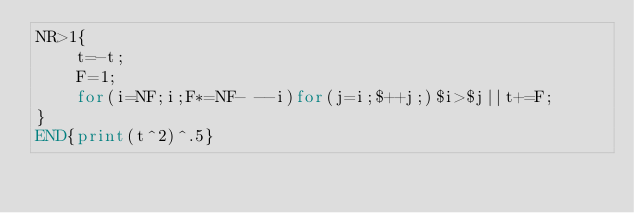Convert code to text. <code><loc_0><loc_0><loc_500><loc_500><_Awk_>NR>1{
	t=-t;
	F=1;
	for(i=NF;i;F*=NF- --i)for(j=i;$++j;)$i>$j||t+=F;
}
END{print(t^2)^.5}
</code> 